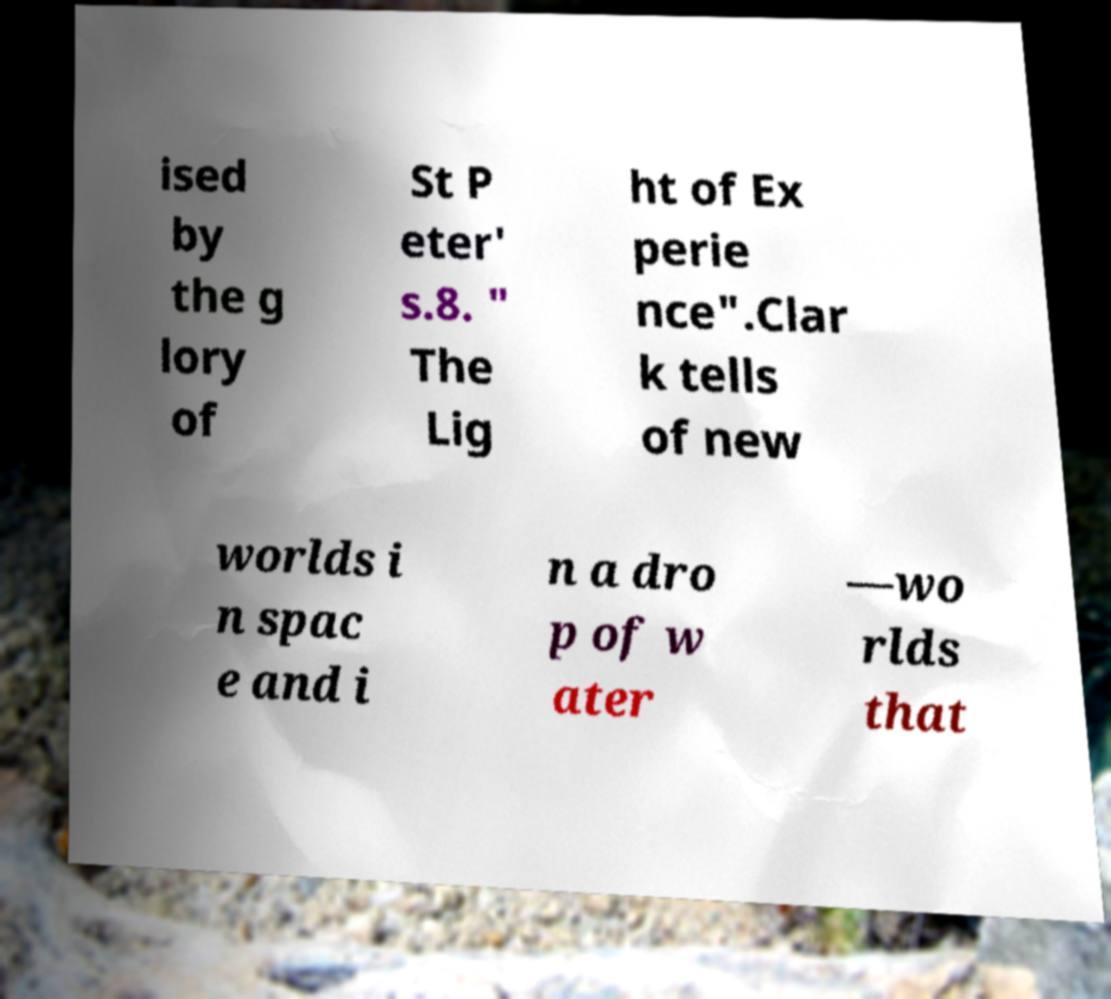There's text embedded in this image that I need extracted. Can you transcribe it verbatim? ised by the g lory of St P eter' s.8. " The Lig ht of Ex perie nce".Clar k tells of new worlds i n spac e and i n a dro p of w ater —wo rlds that 